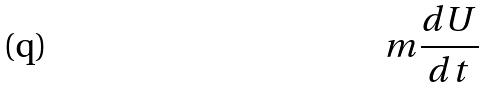<formula> <loc_0><loc_0><loc_500><loc_500>m \frac { d U } { d t }</formula> 